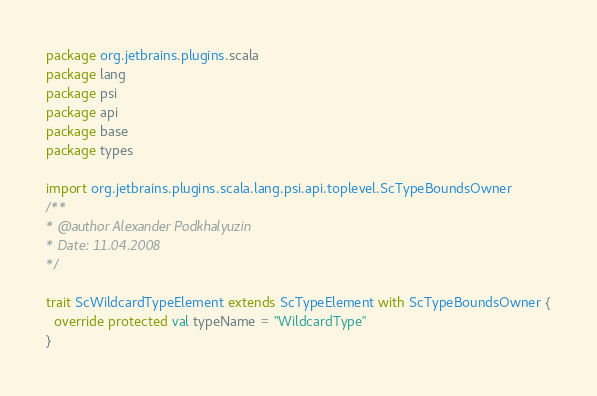Convert code to text. <code><loc_0><loc_0><loc_500><loc_500><_Scala_>package org.jetbrains.plugins.scala
package lang
package psi
package api
package base
package types

import org.jetbrains.plugins.scala.lang.psi.api.toplevel.ScTypeBoundsOwner
/** 
* @author Alexander Podkhalyuzin
* Date: 11.04.2008
*/

trait ScWildcardTypeElement extends ScTypeElement with ScTypeBoundsOwner {
  override protected val typeName = "WildcardType"
}</code> 